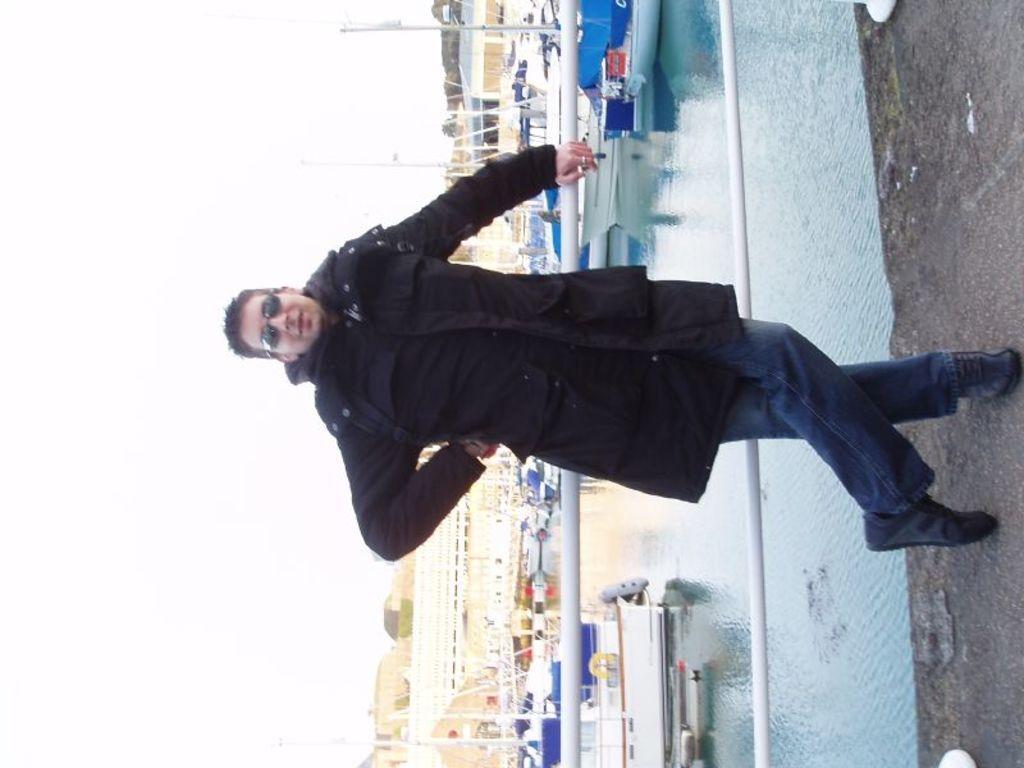How would you summarize this image in a sentence or two? In this image we can see a person standing beside the railing, there are some boats on the ocean, there are houses, also we can see the sky. 